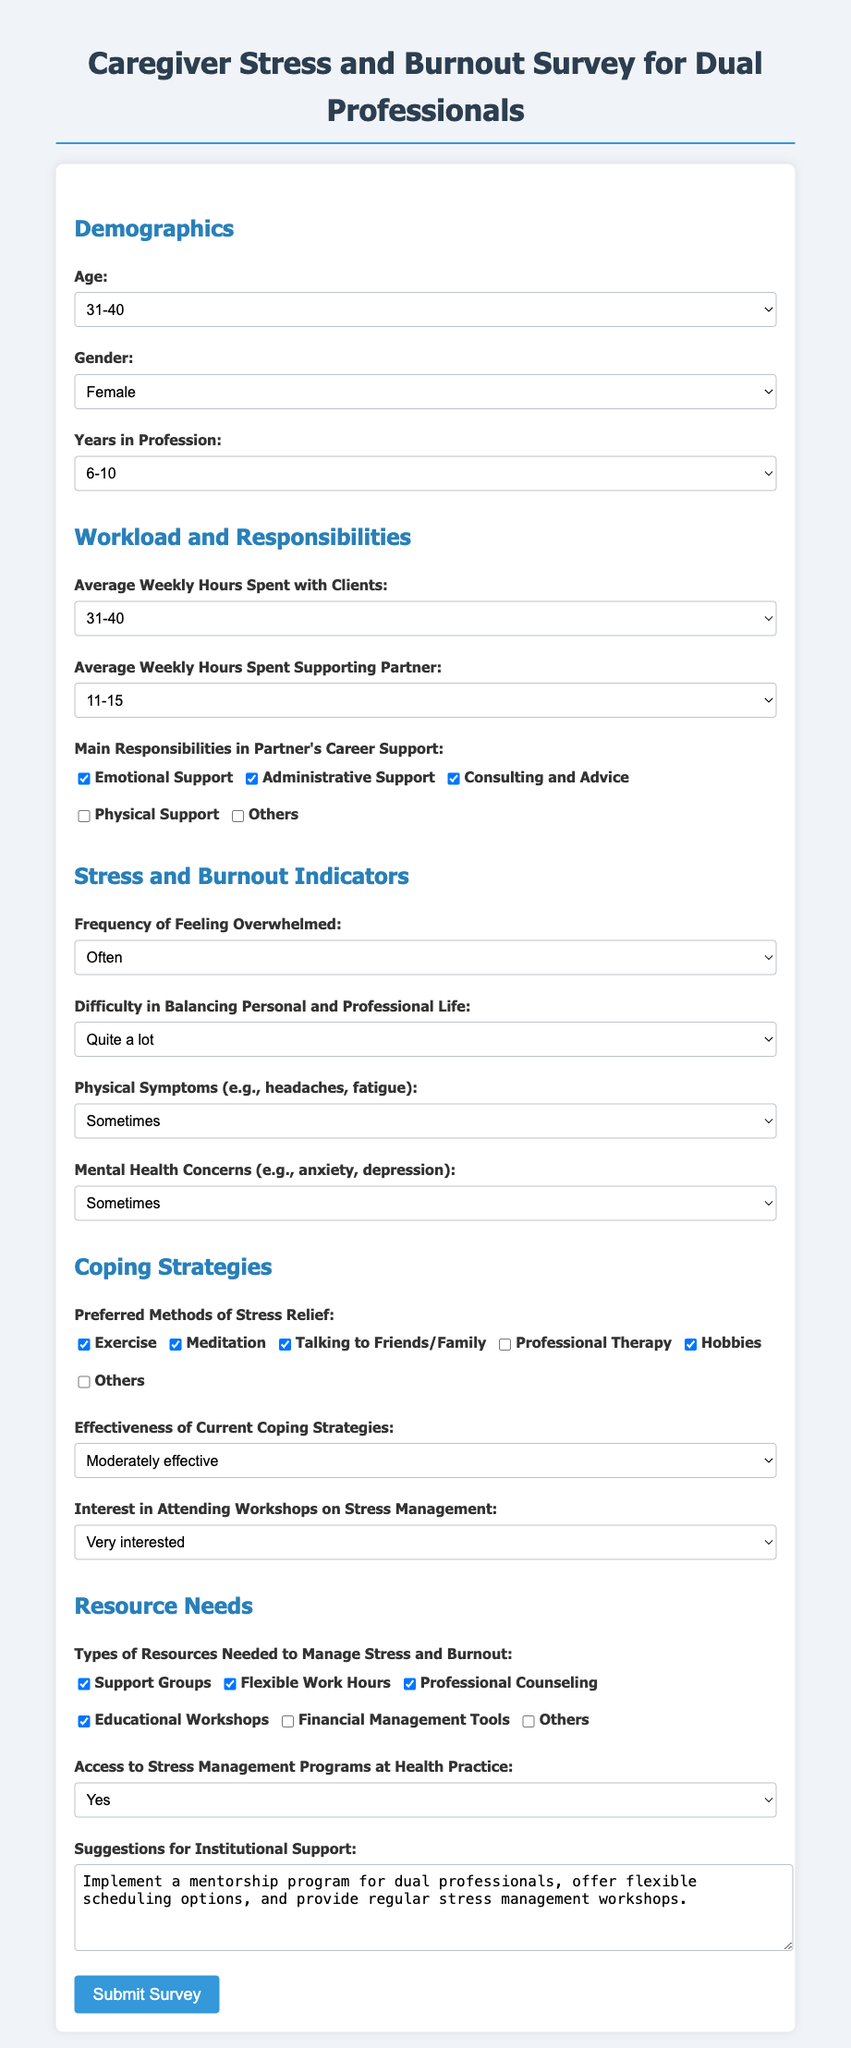What is the selected age range of the respondent? The selected age range for the respondent in the survey is shown in the demographics section.
Answer: 31-40 What is the average weekly hours spent with clients? The average weekly hours spent with clients is indicated in the workload and responsibilities section.
Answer: 31-40 How often does the respondent feel overwhelmed? The frequency of feeling overwhelmed is detailed in the stress and burnout indicators section.
Answer: Often What are the preferred methods of stress relief checked by the respondent? The preferred methods of stress relief are listed in the coping strategies section, highlighting the selected options.
Answer: Exercise, Meditation, Talking to Friends/Family, Hobbies What type of resources is the respondent interested in to manage stress and burnout? The types of resources needed are specified in the resource needs section.
Answer: Support Groups, Flexible Work Hours, Professional Counseling, Educational Workshops What suggestion did the respondent provide for institutional support? Suggestions for institutional support are explicitly mentioned in a text area towards the end of the survey.
Answer: Implement a mentorship program for dual professionals, offer flexible scheduling options, and provide regular stress management workshops 